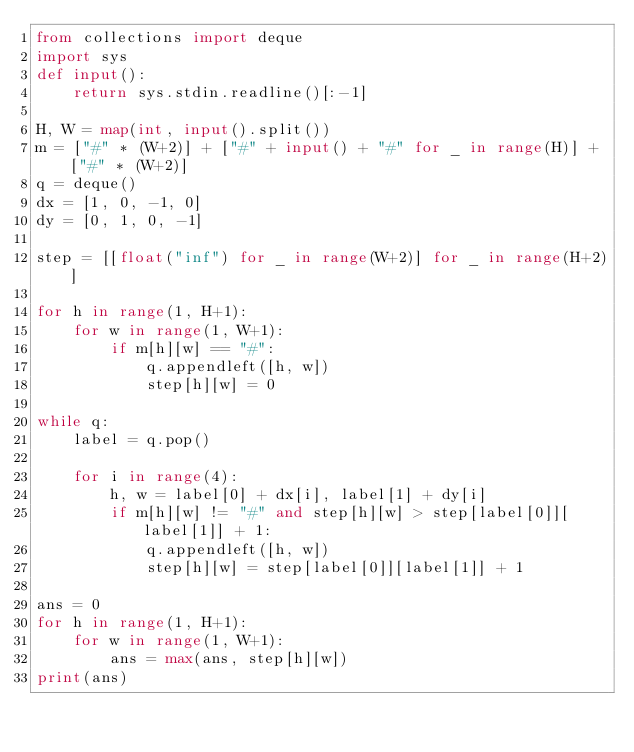Convert code to text. <code><loc_0><loc_0><loc_500><loc_500><_Python_>from collections import deque
import sys
def input():
	return sys.stdin.readline()[:-1]

H, W = map(int, input().split())
m = ["#" * (W+2)] + ["#" + input() + "#" for _ in range(H)] + ["#" * (W+2)]
q = deque()
dx = [1, 0, -1, 0]
dy = [0, 1, 0, -1]

step = [[float("inf") for _ in range(W+2)] for _ in range(H+2)]

for h in range(1, H+1):
	for w in range(1, W+1):
		if m[h][w] == "#":
			q.appendleft([h, w])
			step[h][w] = 0

while q:
	label = q.pop()

	for i in range(4):
		h, w = label[0] + dx[i], label[1] + dy[i]
		if m[h][w] != "#" and step[h][w] > step[label[0]][label[1]] + 1:
			q.appendleft([h, w])
			step[h][w] = step[label[0]][label[1]] + 1

ans = 0
for h in range(1, H+1):
	for w in range(1, W+1):
		ans = max(ans, step[h][w])
print(ans)</code> 